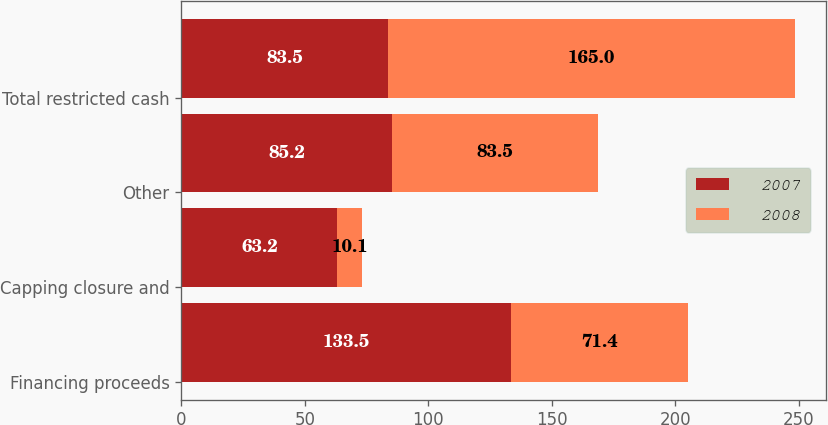Convert chart. <chart><loc_0><loc_0><loc_500><loc_500><stacked_bar_chart><ecel><fcel>Financing proceeds<fcel>Capping closure and<fcel>Other<fcel>Total restricted cash<nl><fcel>2007<fcel>133.5<fcel>63.2<fcel>85.2<fcel>83.5<nl><fcel>2008<fcel>71.4<fcel>10.1<fcel>83.5<fcel>165<nl></chart> 